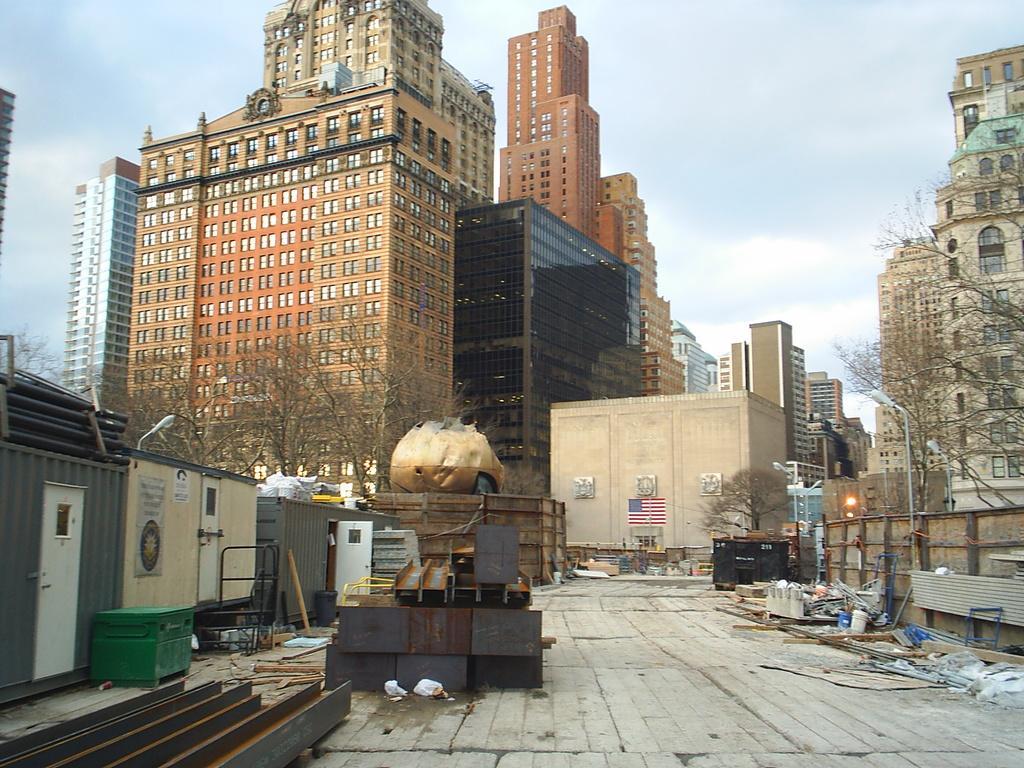Describe this image in one or two sentences. In front of the image there are some objects on the surface. In the background of the image there are buildings, trees, street lights. At the top of the image there is sky. 